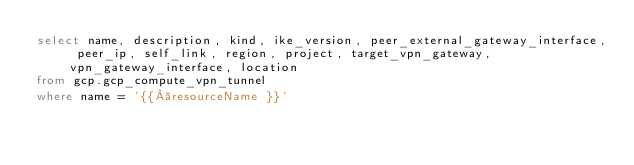Convert code to text. <code><loc_0><loc_0><loc_500><loc_500><_SQL_>select name, description, kind, ike_version, peer_external_gateway_interface, peer_ip, self_link, region, project, target_vpn_gateway, vpn_gateway_interface, location
from gcp.gcp_compute_vpn_tunnel
where name = '{{ resourceName }}'</code> 